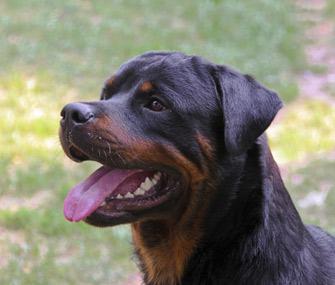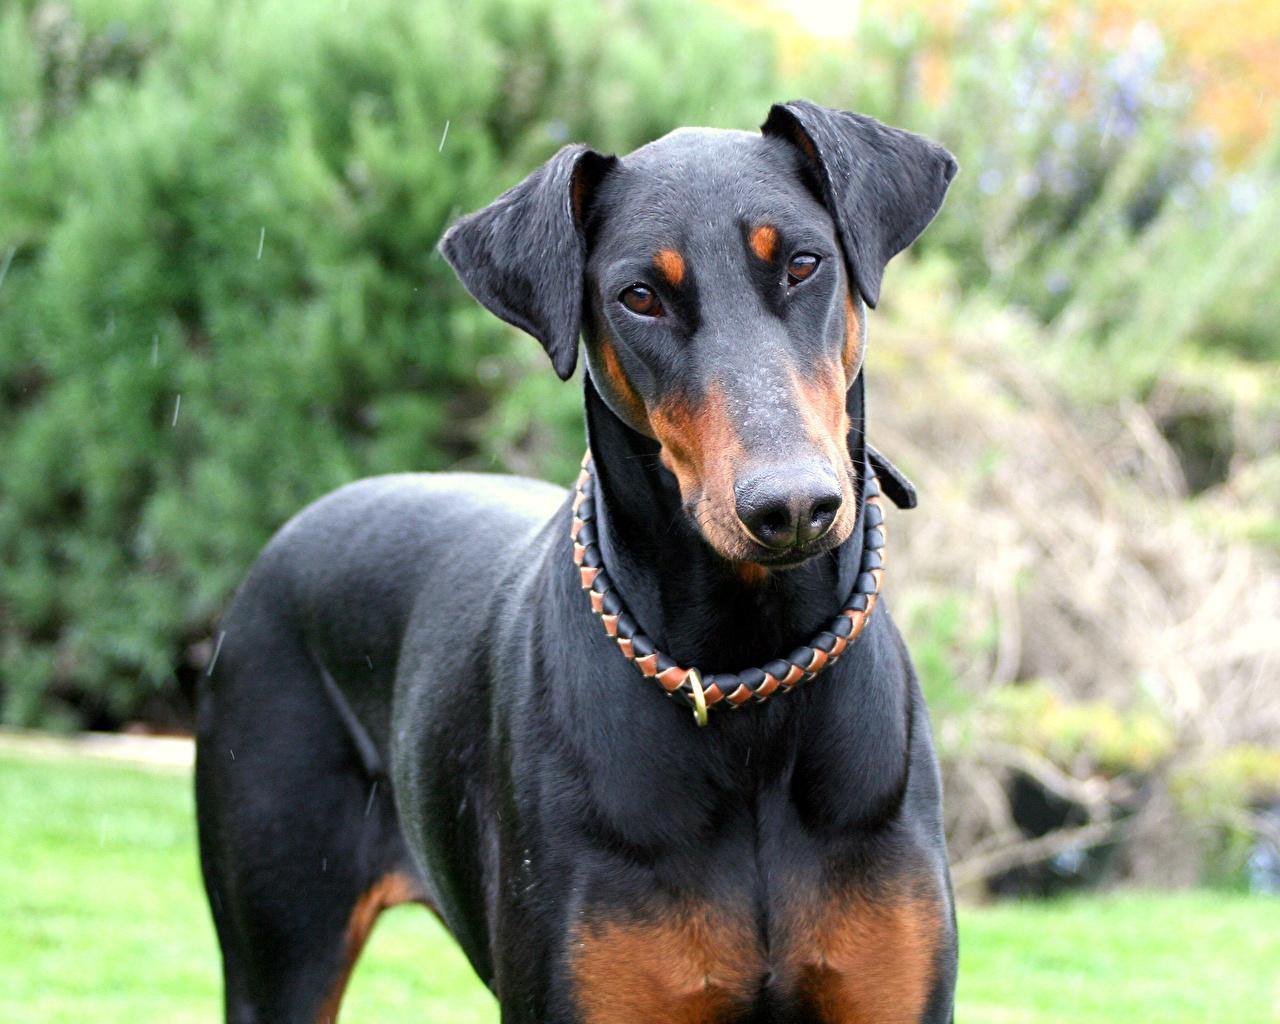The first image is the image on the left, the second image is the image on the right. For the images shown, is this caption "The dog in the image on the left is wearing a collar and hanging its tongue out." true? Answer yes or no. No. The first image is the image on the left, the second image is the image on the right. Considering the images on both sides, is "Each image features one adult doberman with erect ears and upright head, and the dog on the left wears something spiky around its neck." valid? Answer yes or no. No. 